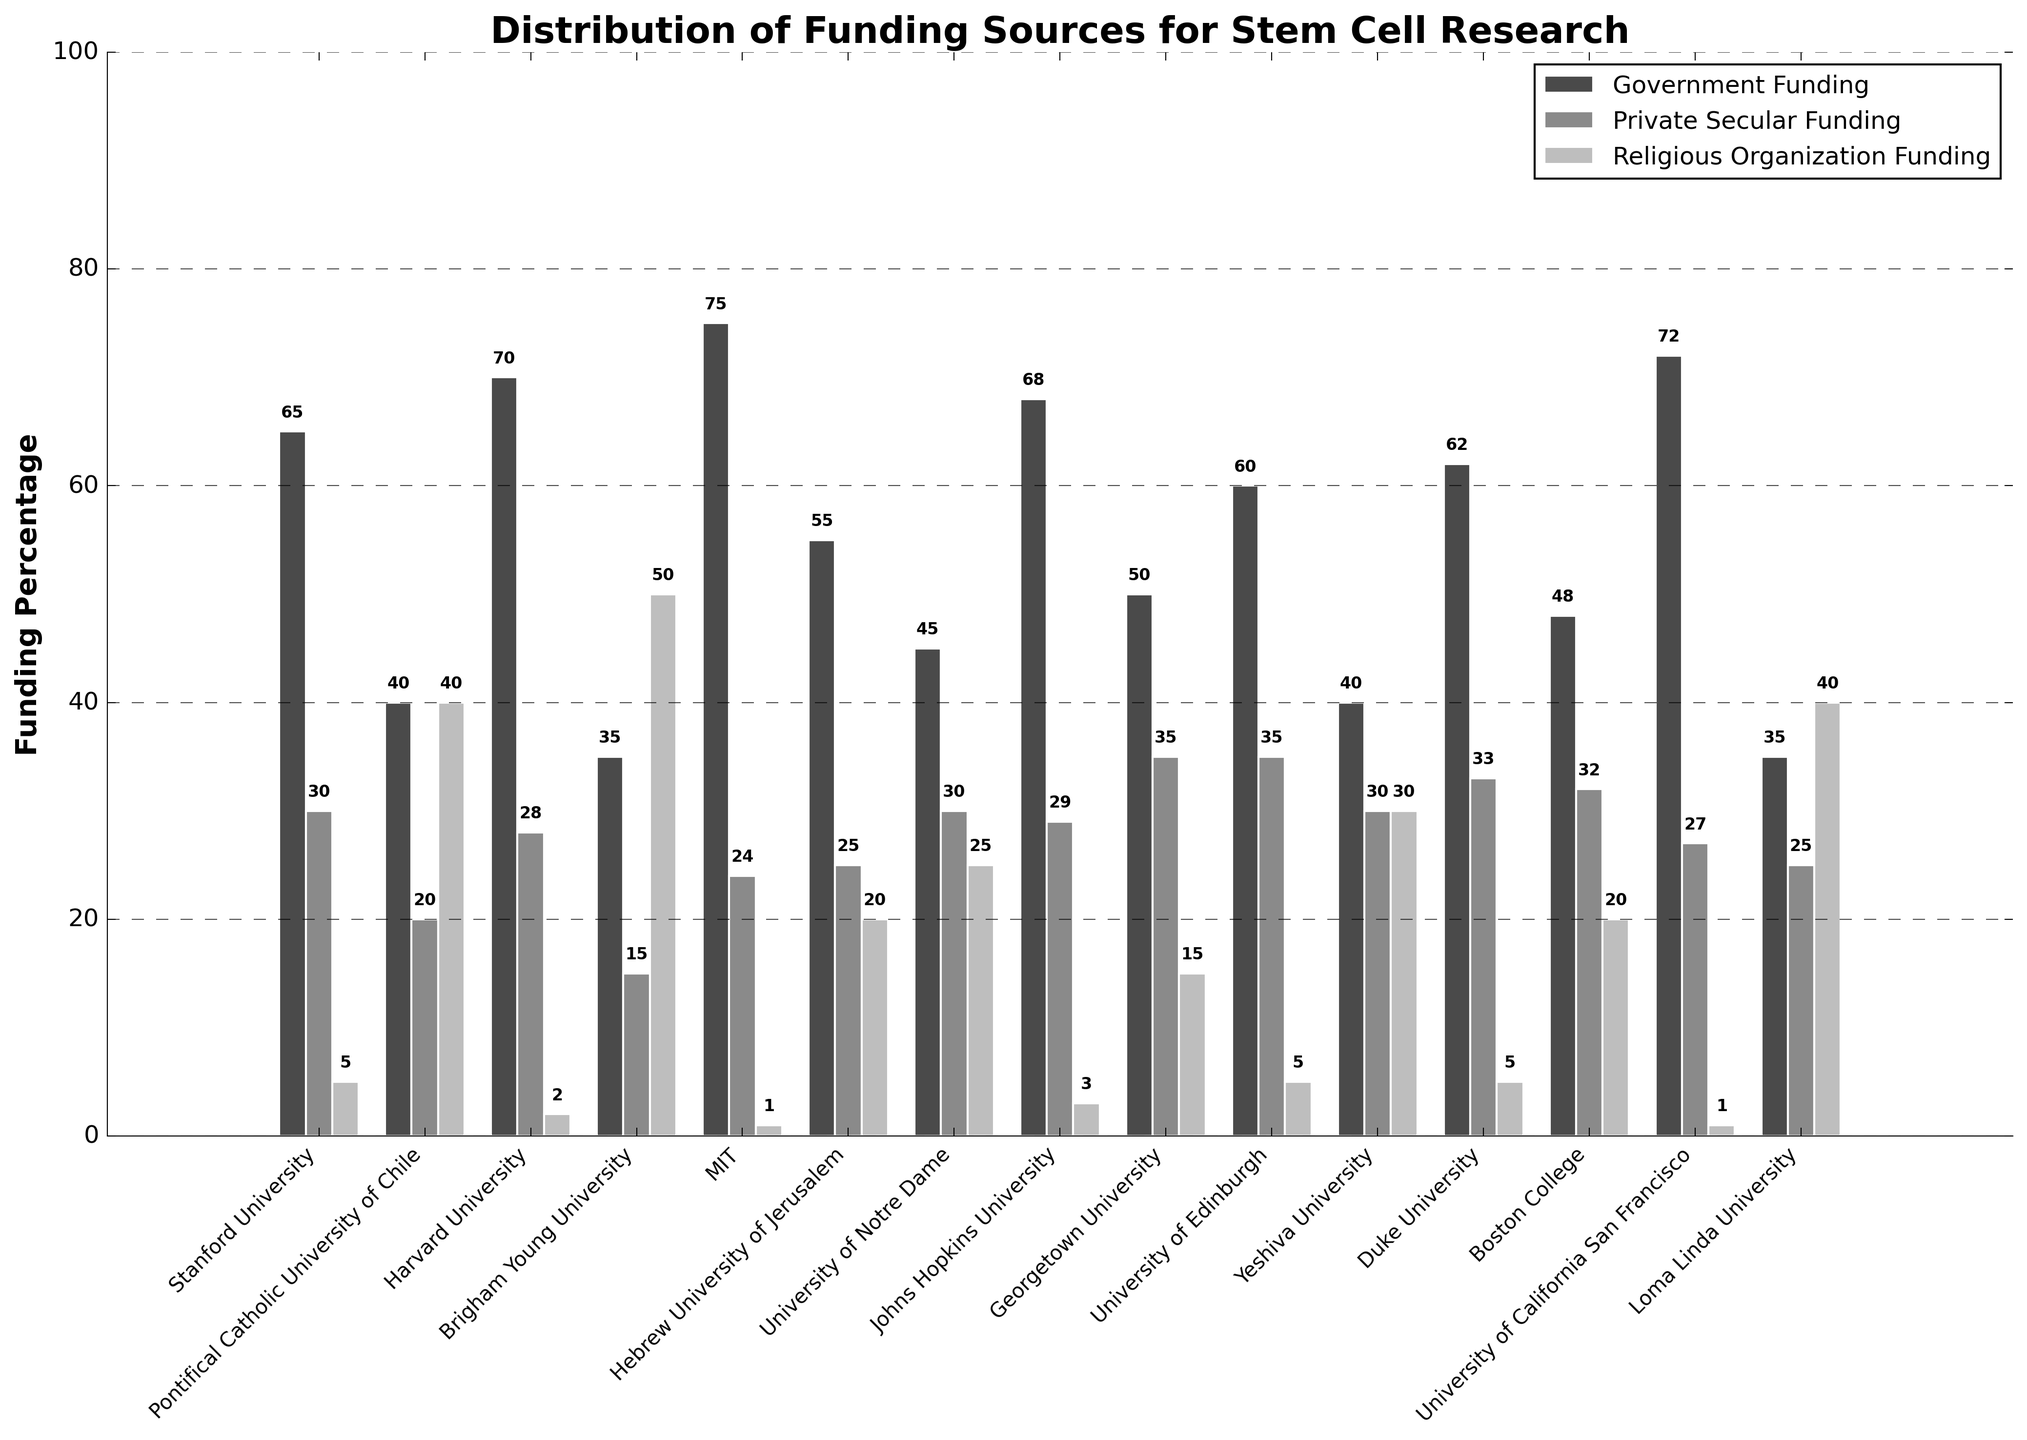What's the percentage of government funding for the highest-funded institution? The highest percentage of government funding is clearly visible for MIT, where this sector reaches 75%.
Answer: 75% Compared to Stanford University, how much more private secular funding does Georgetown University receive? Stanford University receives 30% private secular funding while Georgetown University receives 35%. The difference is 35% - 30% = 5%.
Answer: 5% Which institution has the highest percentage of religious organization funding, and what's that percentage? By looking at the tallest bar in the religious funding category, Brigham Young University receives the highest percentage at 50%.
Answer: Brigham Young University, 50% What's the combined funding percentage from private secular and religious organization sources for Boston College? Boston College has 32% private secular funding and 20% religious organization funding. Adding these together gives 32% + 20% = 52%.
Answer: 52% Which institution gets more government funding, University of Notre Dame or Hebrew University of Jerusalem? The University of Notre Dame receives 45% government funding, while the Hebrew University of Jerusalem receives 55%. The Hebrew University of Jerusalem receives more.
Answer: Hebrew University of Jerusalem What is the average government funding percentage across all listed institutions? Sum the government funding percentages: 65 + 40 + 70 + 35 + 75 + 55 + 45 + 68 + 50 + 60 + 40 + 62 + 48 + 72 + 35 = 820. The total number of institutions is 15. So, the average is 820 / 15 = 54.67%.
Answer: 54.67% Are there any institutions where private secular funding is higher than government funding? By analyzing the bars for private secular and government funding, no institution has private secular funding surpassing government funding.
Answer: No Does any institution receive equal funding from government and religious organizations? After checking the funding percentages, no institution has equal values between government and religious organization funding.
Answer: No What's the total percentage of private secular funding for all listed institutions combined? Sum the private secular funding percentages: 30 + 20 + 28 + 15 + 24 + 25 + 30 + 29 + 35 + 35 + 30 + 33 + 32 + 27 + 25. This equals 418%.
Answer: 418% Which institution receives the lowest percentage of government funding, and what is that percentage? The lowest government funding percentage is observed at Brigham Young University with 35%.
Answer: Brigham Young University, 35% 